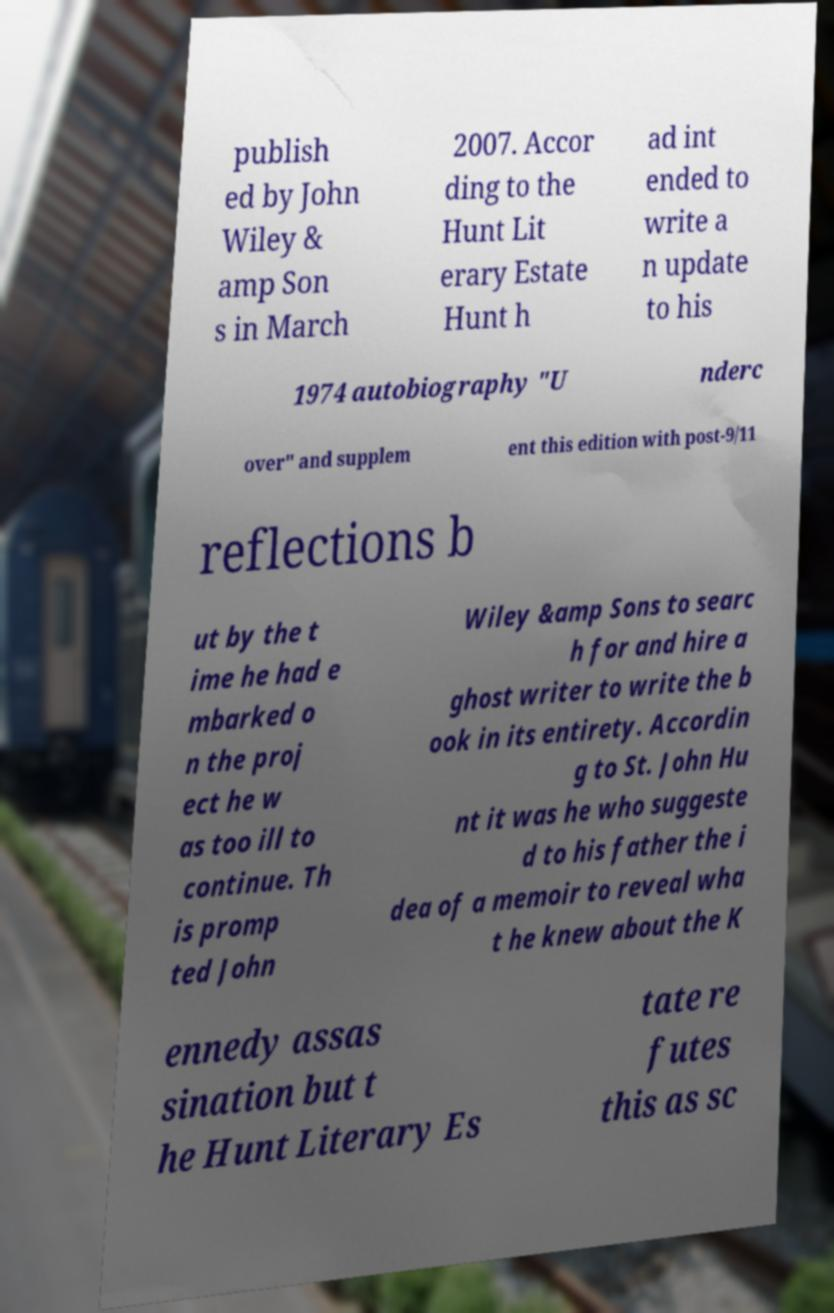What messages or text are displayed in this image? I need them in a readable, typed format. publish ed by John Wiley & amp Son s in March 2007. Accor ding to the Hunt Lit erary Estate Hunt h ad int ended to write a n update to his 1974 autobiography "U nderc over" and supplem ent this edition with post-9/11 reflections b ut by the t ime he had e mbarked o n the proj ect he w as too ill to continue. Th is promp ted John Wiley &amp Sons to searc h for and hire a ghost writer to write the b ook in its entirety. Accordin g to St. John Hu nt it was he who suggeste d to his father the i dea of a memoir to reveal wha t he knew about the K ennedy assas sination but t he Hunt Literary Es tate re futes this as sc 